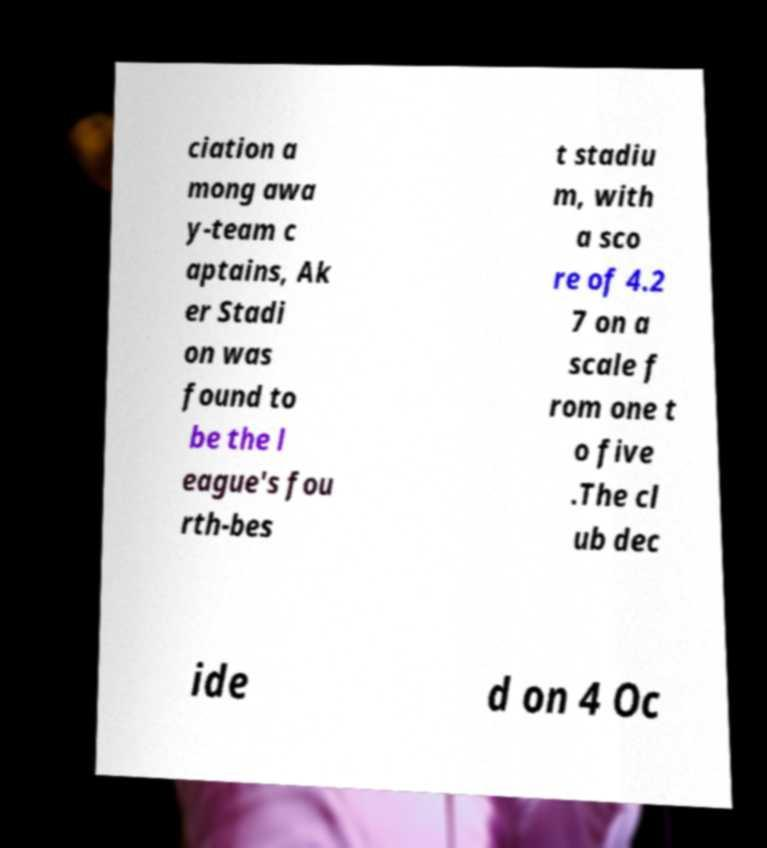Can you read and provide the text displayed in the image?This photo seems to have some interesting text. Can you extract and type it out for me? ciation a mong awa y-team c aptains, Ak er Stadi on was found to be the l eague's fou rth-bes t stadiu m, with a sco re of 4.2 7 on a scale f rom one t o five .The cl ub dec ide d on 4 Oc 